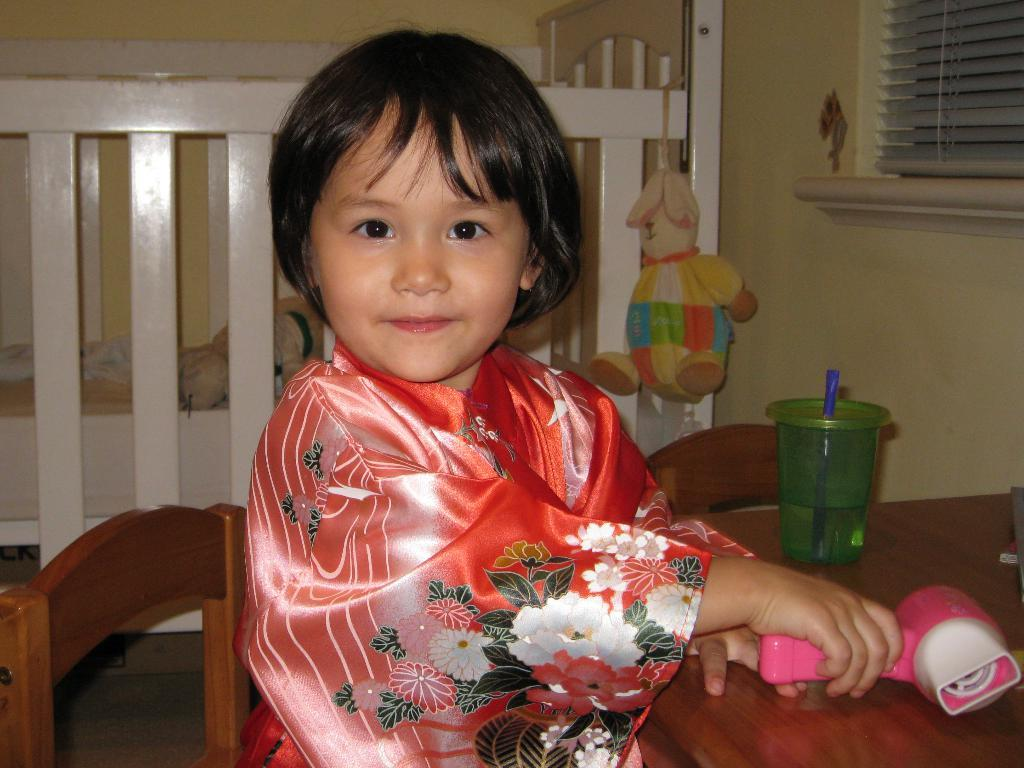What is the main subject of the image? There is a child in the image. What is the child doing in the image? The child is sitting on a chair. Where is the chair located in relation to the table? The chair is in front of a table. What can be seen on the table? There is a glass on the table. What is visible in the background of the image? There is a wall, a window blind, and a children's bed in the background. What type of watch is the child wearing in the image? There is no watch visible on the child in the image. What is the significance of the locket around the child's neck in the image? There is no locket present around the child's neck in the image. 